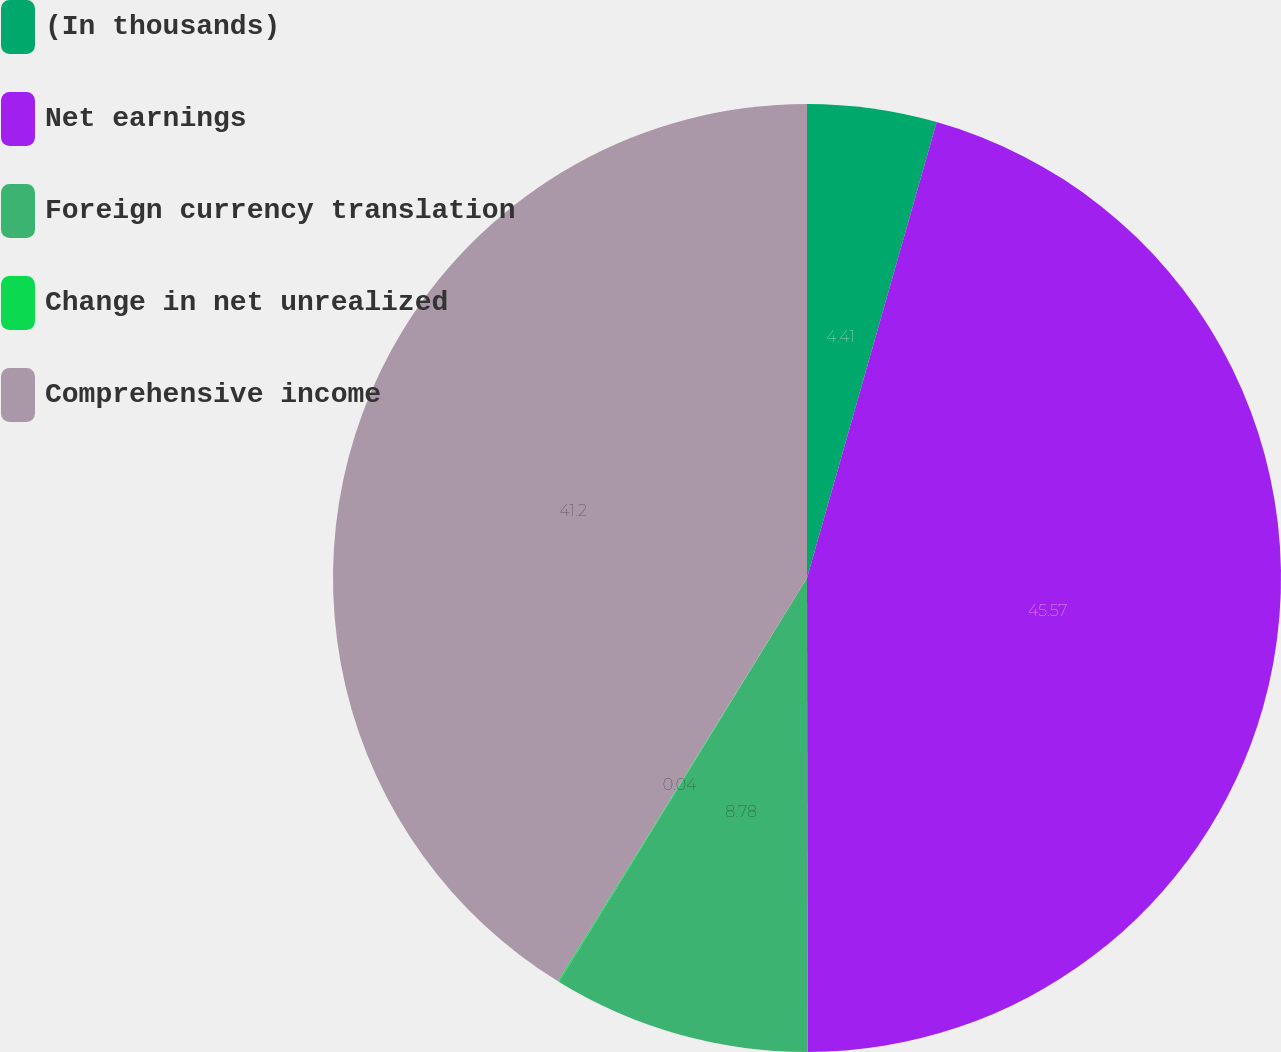Convert chart to OTSL. <chart><loc_0><loc_0><loc_500><loc_500><pie_chart><fcel>(In thousands)<fcel>Net earnings<fcel>Foreign currency translation<fcel>Change in net unrealized<fcel>Comprehensive income<nl><fcel>4.41%<fcel>45.56%<fcel>8.78%<fcel>0.04%<fcel>41.19%<nl></chart> 